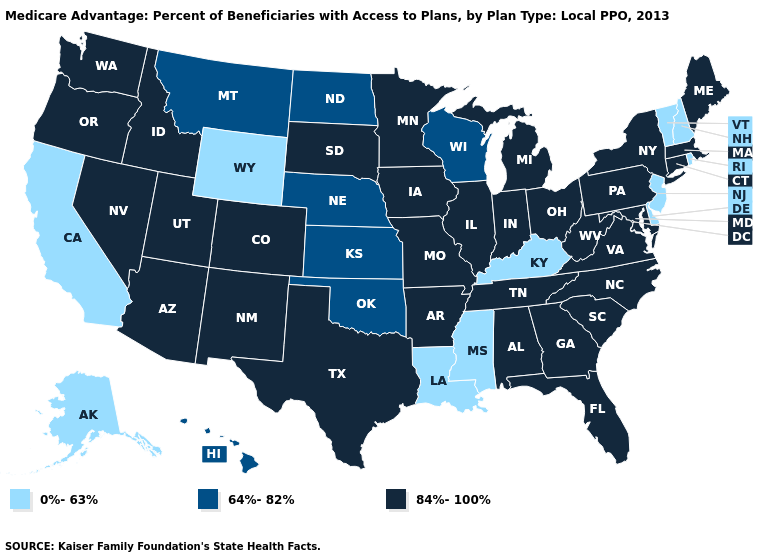Name the states that have a value in the range 64%-82%?
Keep it brief. Hawaii, Kansas, Montana, North Dakota, Nebraska, Oklahoma, Wisconsin. Name the states that have a value in the range 84%-100%?
Be succinct. Alabama, Arkansas, Arizona, Colorado, Connecticut, Florida, Georgia, Iowa, Idaho, Illinois, Indiana, Massachusetts, Maryland, Maine, Michigan, Minnesota, Missouri, North Carolina, New Mexico, Nevada, New York, Ohio, Oregon, Pennsylvania, South Carolina, South Dakota, Tennessee, Texas, Utah, Virginia, Washington, West Virginia. How many symbols are there in the legend?
Answer briefly. 3. What is the value of Mississippi?
Be succinct. 0%-63%. Among the states that border Mississippi , does Louisiana have the highest value?
Answer briefly. No. What is the value of Nebraska?
Answer briefly. 64%-82%. What is the value of Idaho?
Keep it brief. 84%-100%. What is the value of South Dakota?
Keep it brief. 84%-100%. Name the states that have a value in the range 84%-100%?
Answer briefly. Alabama, Arkansas, Arizona, Colorado, Connecticut, Florida, Georgia, Iowa, Idaho, Illinois, Indiana, Massachusetts, Maryland, Maine, Michigan, Minnesota, Missouri, North Carolina, New Mexico, Nevada, New York, Ohio, Oregon, Pennsylvania, South Carolina, South Dakota, Tennessee, Texas, Utah, Virginia, Washington, West Virginia. What is the value of Massachusetts?
Give a very brief answer. 84%-100%. Is the legend a continuous bar?
Short answer required. No. Is the legend a continuous bar?
Quick response, please. No. How many symbols are there in the legend?
Concise answer only. 3. What is the value of North Dakota?
Quick response, please. 64%-82%. What is the highest value in the USA?
Write a very short answer. 84%-100%. 